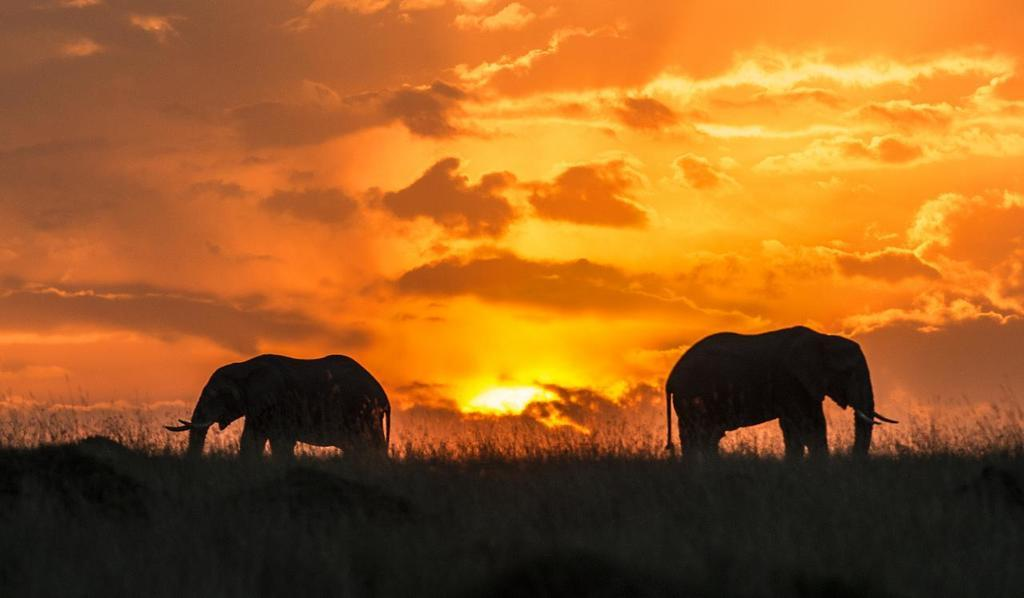What animals are present on the ground in the image? There are two elephants on the ground in the image. What type of vegetation can be seen in the image? There is grass visible in the image. What celestial body is visible in the image? The sun is visible in the image. How would you describe the sky in the image? The sky appears cloudy in the image. Where is the can of paint located in the image? There is no can of paint present in the image. Is there a river visible in the image? No, there is no river visible in the image. Are there any cacti present in the image? No, there are no cacti present in the image. 